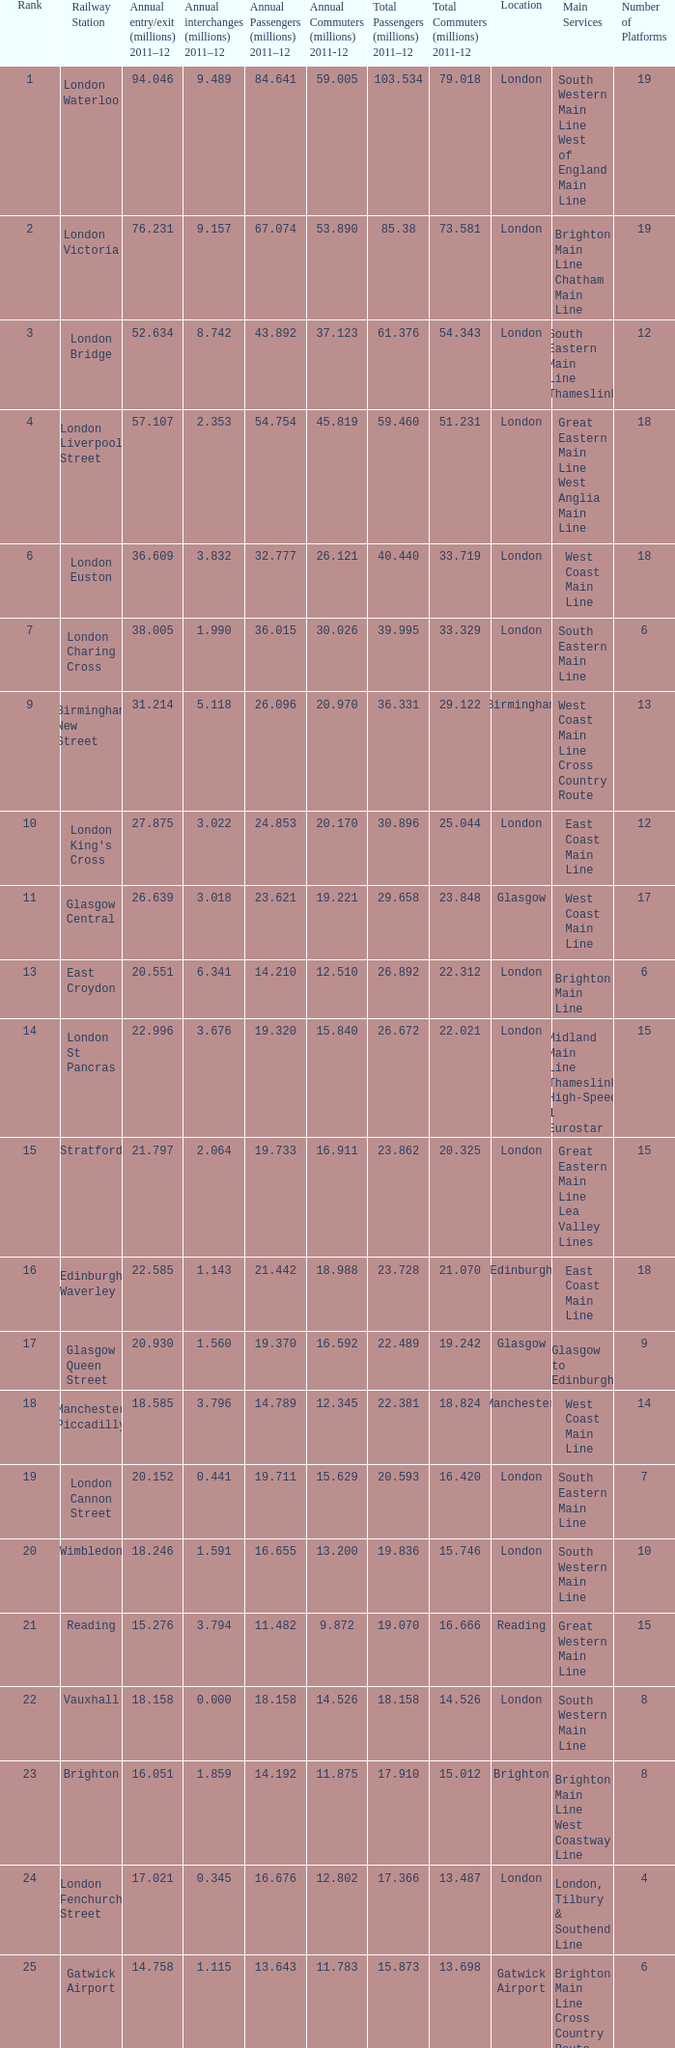Which location has 103.534 million passengers in 2011-12?  London. 